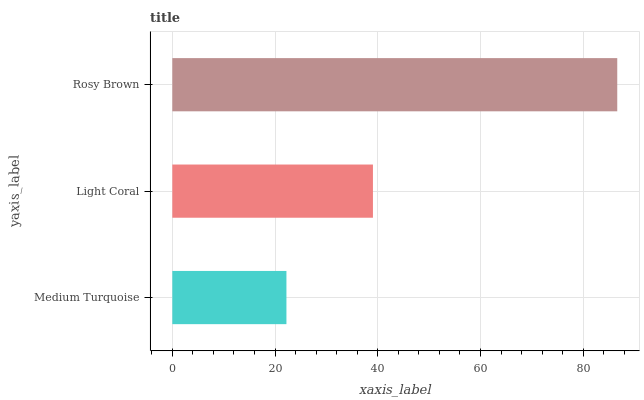Is Medium Turquoise the minimum?
Answer yes or no. Yes. Is Rosy Brown the maximum?
Answer yes or no. Yes. Is Light Coral the minimum?
Answer yes or no. No. Is Light Coral the maximum?
Answer yes or no. No. Is Light Coral greater than Medium Turquoise?
Answer yes or no. Yes. Is Medium Turquoise less than Light Coral?
Answer yes or no. Yes. Is Medium Turquoise greater than Light Coral?
Answer yes or no. No. Is Light Coral less than Medium Turquoise?
Answer yes or no. No. Is Light Coral the high median?
Answer yes or no. Yes. Is Light Coral the low median?
Answer yes or no. Yes. Is Rosy Brown the high median?
Answer yes or no. No. Is Rosy Brown the low median?
Answer yes or no. No. 